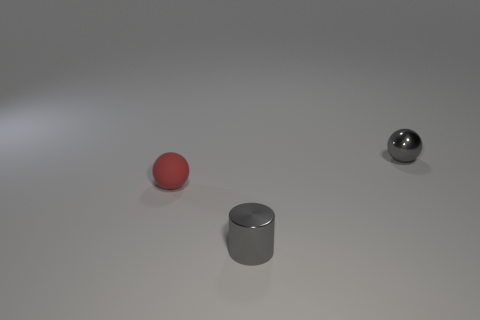Add 1 small yellow balls. How many objects exist? 4 Subtract 1 cylinders. How many cylinders are left? 0 Subtract all red balls. How many balls are left? 1 Subtract all green cylinders. How many cyan balls are left? 0 Subtract all spheres. How many objects are left? 1 Subtract all brown spheres. Subtract all blue cubes. How many spheres are left? 2 Subtract all red spheres. Subtract all gray metal things. How many objects are left? 0 Add 2 small metallic cylinders. How many small metallic cylinders are left? 3 Add 2 blue metal blocks. How many blue metal blocks exist? 2 Subtract 0 yellow cubes. How many objects are left? 3 